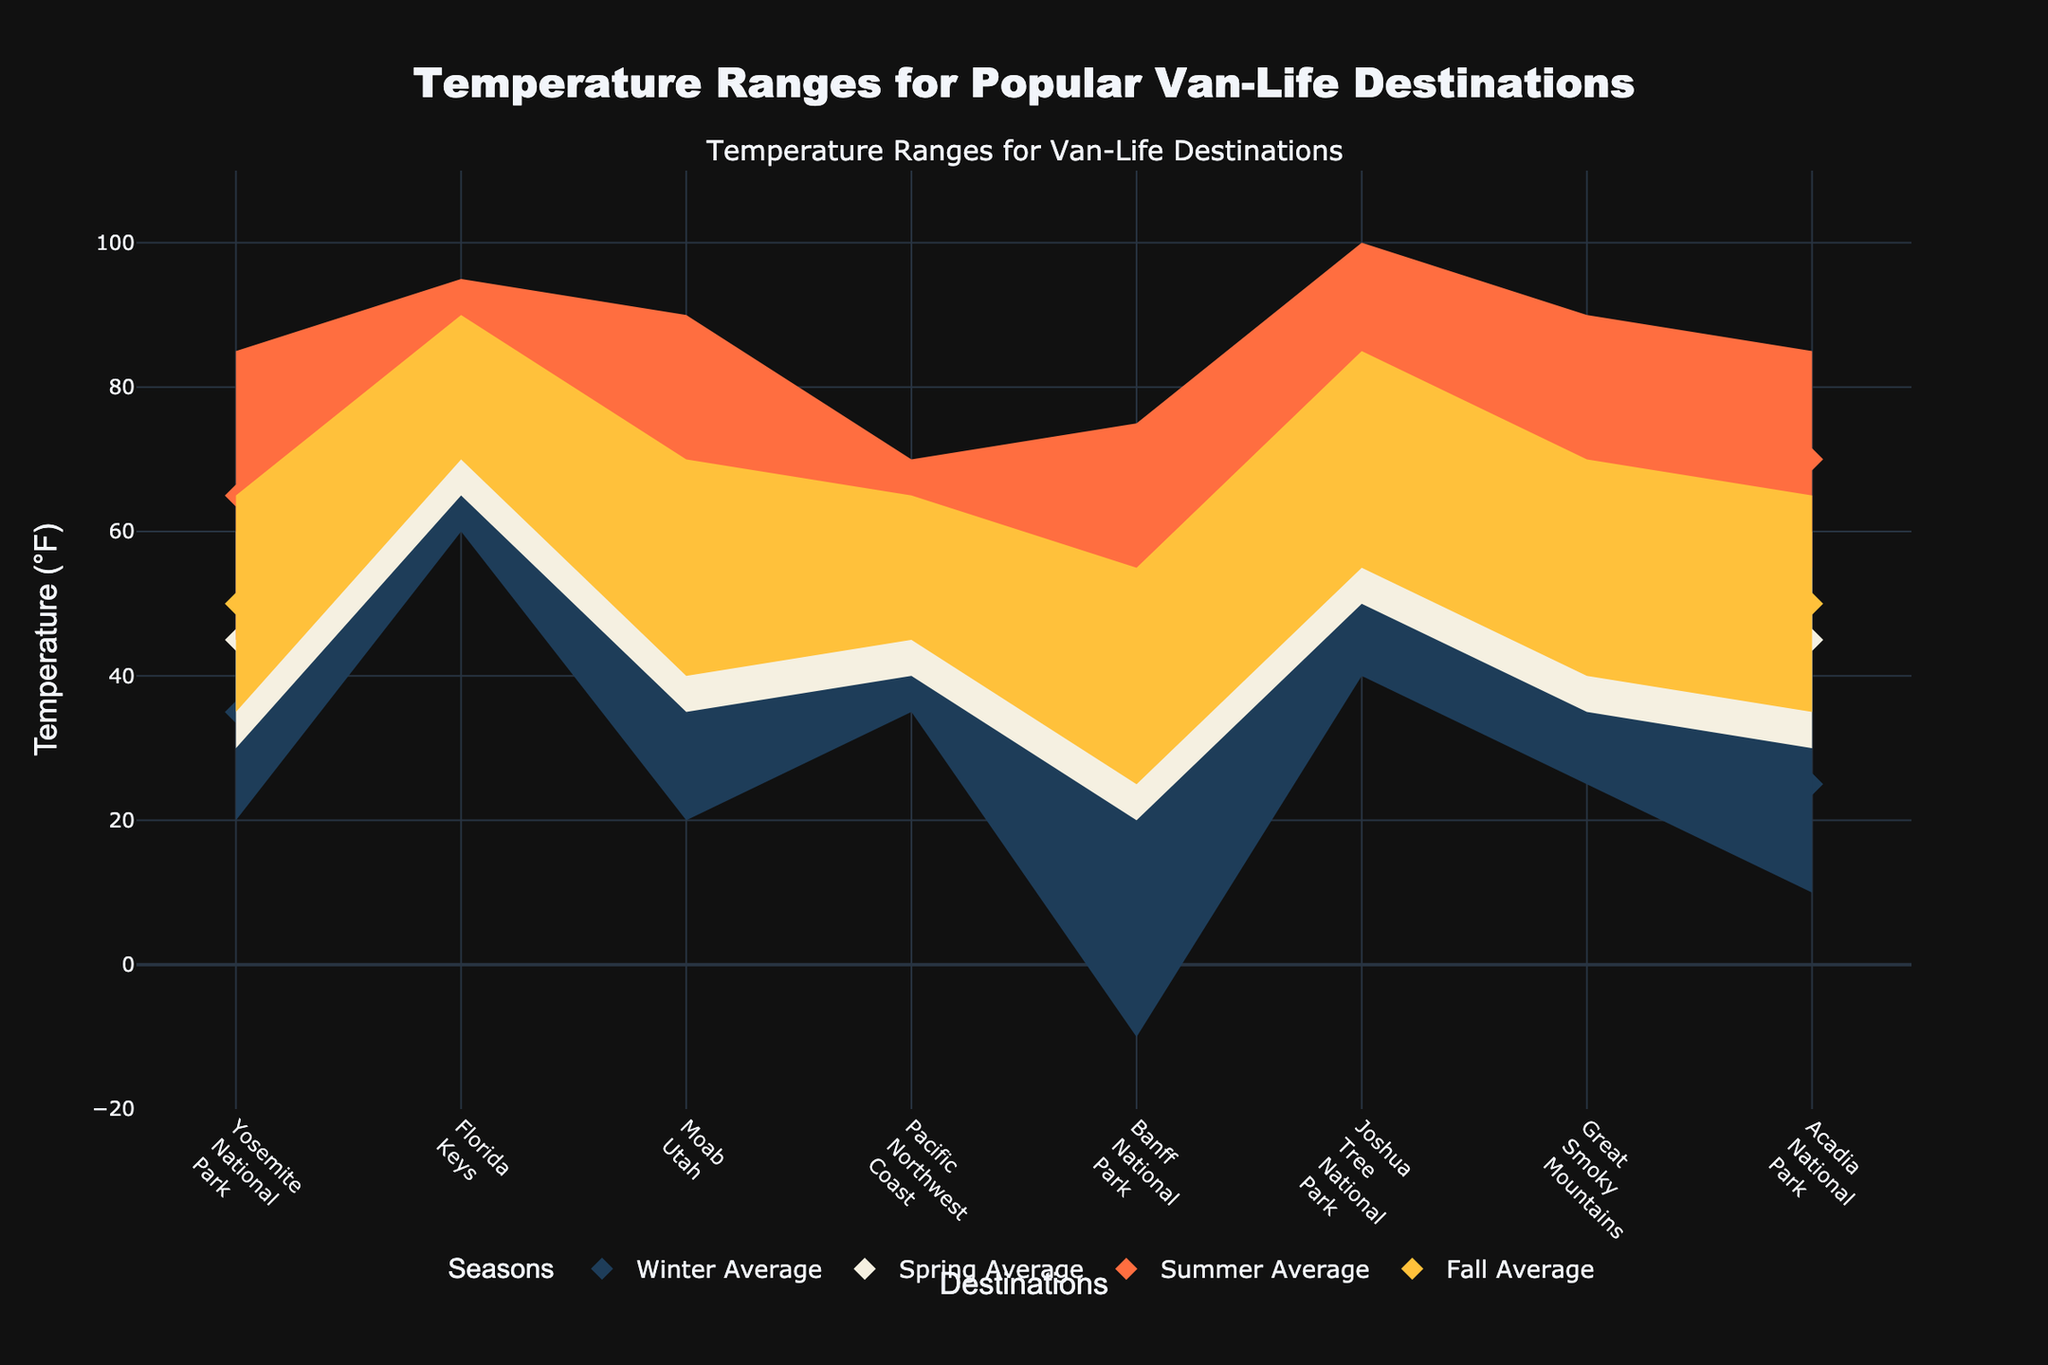what are the average winter temperatures across all locations? To find the average winter temperature across all locations, locate the 'Winter Avg' markers on the plot. Note the values for each destination and calculate the average by summing these values and dividing by the number of destinations. The values are 35, 70, 35, 45, 5, 55, 40, and 25, respectively. Sum them up to get 310, then divide by 8 to get approximately 38.75°F.
Answer: 38.75°F Which location experiences the highest summer temperatures? Locate the 'Summer High' temperatures on the plot, identified as the upper boundary of the summer range. Compare these high points across all locations. Yosemite (85°F), Florida Keys (95°F), Moab (90°F), Pacific Northwest (70°F), Banff (75°F), Joshua Tree (100°F), Great Smoky Mountains (90°F), Acadia (85°F). Joshua Tree has the highest, at 100°F.
Answer: Joshua Tree What is the temperature range for the Florida Keys in winter? For the Florida Keys in winter, note the lowest and highest temperatures marked in the 'Winter' section of the plot. The temperatures are between 60°F and 80°F. The range is the difference between these values, which is 80 - 60 = 20°F.
Answer: 20°F Compare the average summer temperatures between Yosemite and the Pacific Northwest coast. Compare the 'Summer Avg' temperatures for both locations. Yosemite shows an average of 65°F, and the Pacific Northwest coast shows an average of 60°F. Determine which is higher by direct comparison.
Answer: Yosemite 65°F vs. Pacific Northwest Coast 60°F What is the span of the temperature range in Banff National Park during the winter? Find Banff's 'Winter Low' and 'Winter High' temperatures on the plot. The lowest is -10°F and the highest is 20°F. Calculate the range by subtracting: 20 - (-10) = 30°F.
Answer: 30°F Which location has the smallest difference between the high and low temperatures in spring? Evaluate the 'Spring High' and 'Spring Low' temperatures for each location. Calculate the difference: Yosemite (60-30=30°F), Florida Keys (85-65=20°F), Moab (65-35=30°F), Pacific Northwest Coast (60-40=20°F), Banff (50-20=30°F), Joshua Tree (80-50=30°F), Great Smoky Mountains (65-35=30°F), Acadia (60-30=30°F). The Florida Keys and Pacific Northwest Coast both have the smallest difference of 20°F.
Answer: Florida Keys and Pacific Northwest Coast During which season does Joshua Tree National Park experience the highest temperatures, and what is that temperature? Look at the high temperatures for Joshua Tree across all seasons. Compare Winter (70°F), Spring (80°F), Summer (100°F), and Fall (85°F). The highest temperature is in Summer, at 100°F.
Answer: Summer, 100°F What is the average fall temperature range across all locations? Determine the 'Fall Low' and 'Fall High' temperatures for each location. Calculate the range for each location, then compute the average range. Yosemite (65-35=30°F), Florida Keys (90-70=20°F), Moab (70-40=30°F), Pacific Northwest (65-45=20°F), Banff (55-25=30°F), Joshua Tree (85-55=30°F), Great Smoky Mountains (70-40=30°F), Acadia (65-35=30°F). Average these ranges: (30+20+30+20+30+30+30+30)/8 = 27.5°F.
Answer: 27.5°F 